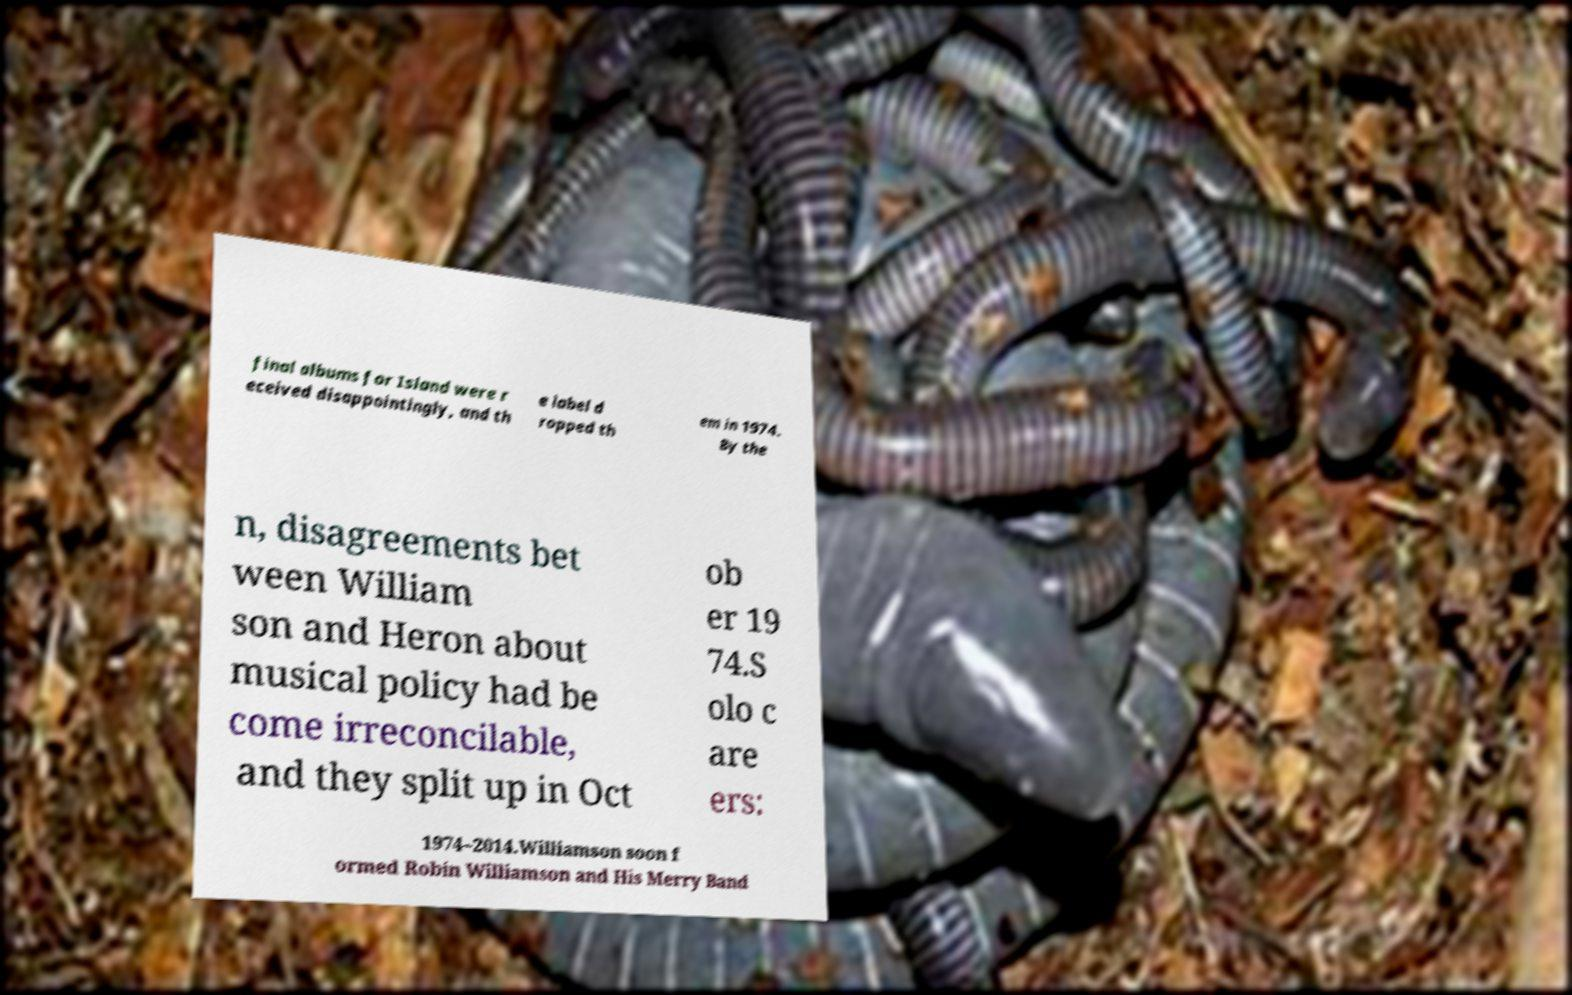What messages or text are displayed in this image? I need them in a readable, typed format. final albums for Island were r eceived disappointingly, and th e label d ropped th em in 1974. By the n, disagreements bet ween William son and Heron about musical policy had be come irreconcilable, and they split up in Oct ob er 19 74.S olo c are ers: 1974–2014.Williamson soon f ormed Robin Williamson and His Merry Band 